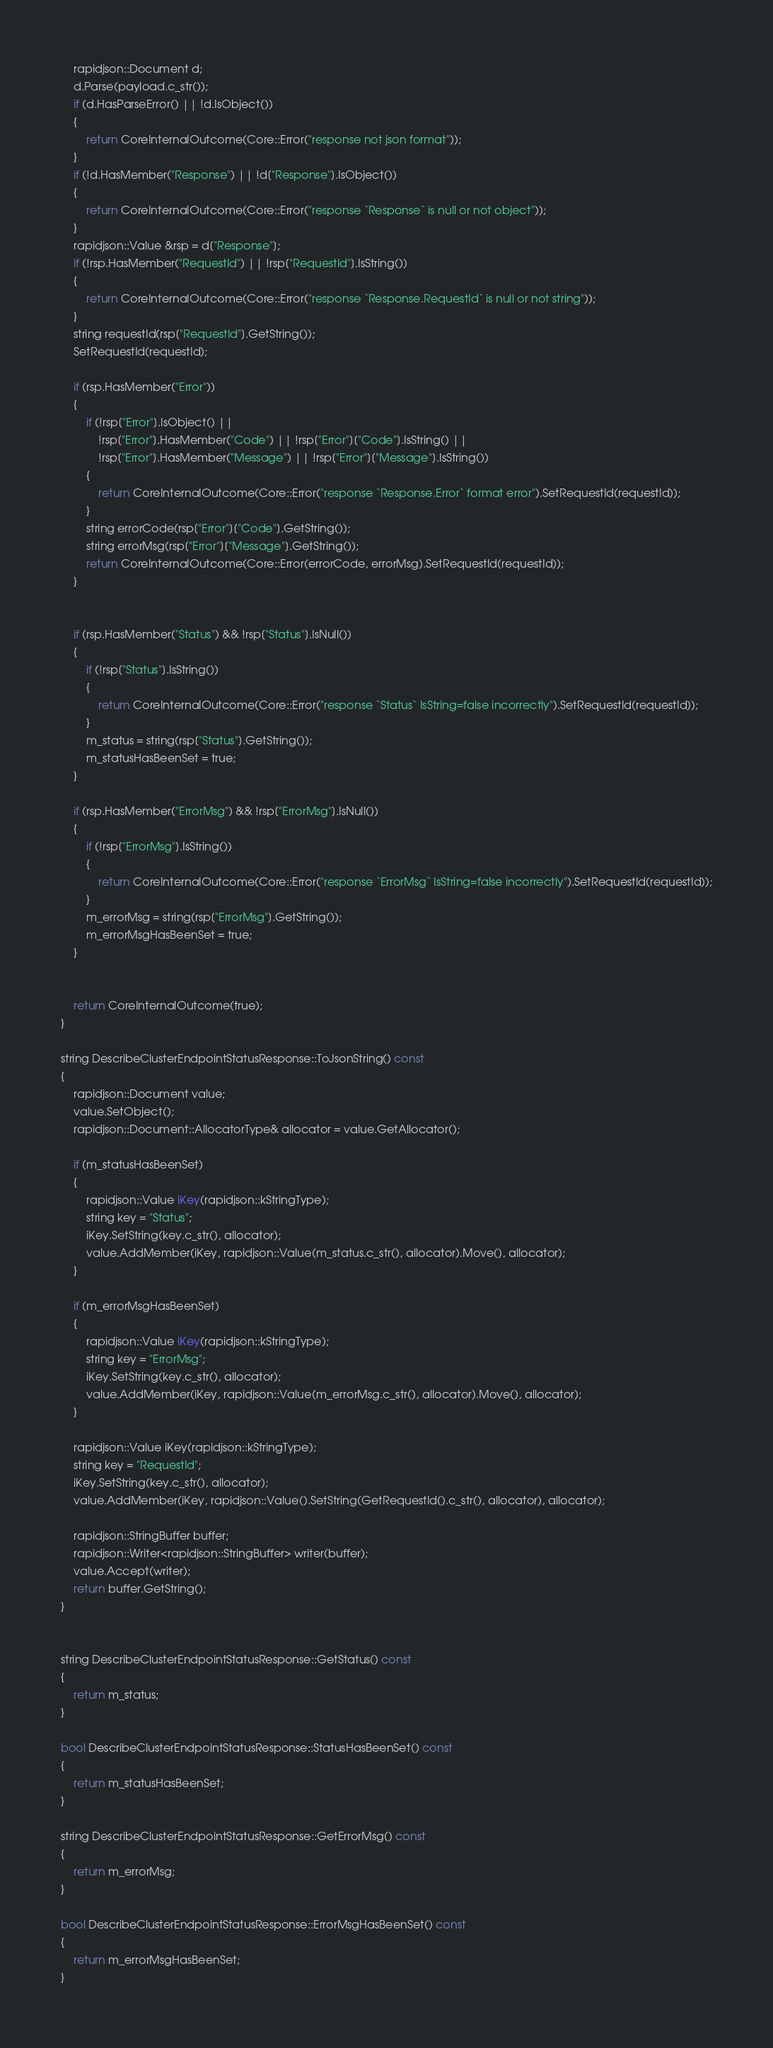<code> <loc_0><loc_0><loc_500><loc_500><_C++_>    rapidjson::Document d;
    d.Parse(payload.c_str());
    if (d.HasParseError() || !d.IsObject())
    {
        return CoreInternalOutcome(Core::Error("response not json format"));
    }
    if (!d.HasMember("Response") || !d["Response"].IsObject())
    {
        return CoreInternalOutcome(Core::Error("response `Response` is null or not object"));
    }
    rapidjson::Value &rsp = d["Response"];
    if (!rsp.HasMember("RequestId") || !rsp["RequestId"].IsString())
    {
        return CoreInternalOutcome(Core::Error("response `Response.RequestId` is null or not string"));
    }
    string requestId(rsp["RequestId"].GetString());
    SetRequestId(requestId);

    if (rsp.HasMember("Error"))
    {
        if (!rsp["Error"].IsObject() ||
            !rsp["Error"].HasMember("Code") || !rsp["Error"]["Code"].IsString() ||
            !rsp["Error"].HasMember("Message") || !rsp["Error"]["Message"].IsString())
        {
            return CoreInternalOutcome(Core::Error("response `Response.Error` format error").SetRequestId(requestId));
        }
        string errorCode(rsp["Error"]["Code"].GetString());
        string errorMsg(rsp["Error"]["Message"].GetString());
        return CoreInternalOutcome(Core::Error(errorCode, errorMsg).SetRequestId(requestId));
    }


    if (rsp.HasMember("Status") && !rsp["Status"].IsNull())
    {
        if (!rsp["Status"].IsString())
        {
            return CoreInternalOutcome(Core::Error("response `Status` IsString=false incorrectly").SetRequestId(requestId));
        }
        m_status = string(rsp["Status"].GetString());
        m_statusHasBeenSet = true;
    }

    if (rsp.HasMember("ErrorMsg") && !rsp["ErrorMsg"].IsNull())
    {
        if (!rsp["ErrorMsg"].IsString())
        {
            return CoreInternalOutcome(Core::Error("response `ErrorMsg` IsString=false incorrectly").SetRequestId(requestId));
        }
        m_errorMsg = string(rsp["ErrorMsg"].GetString());
        m_errorMsgHasBeenSet = true;
    }


    return CoreInternalOutcome(true);
}

string DescribeClusterEndpointStatusResponse::ToJsonString() const
{
    rapidjson::Document value;
    value.SetObject();
    rapidjson::Document::AllocatorType& allocator = value.GetAllocator();

    if (m_statusHasBeenSet)
    {
        rapidjson::Value iKey(rapidjson::kStringType);
        string key = "Status";
        iKey.SetString(key.c_str(), allocator);
        value.AddMember(iKey, rapidjson::Value(m_status.c_str(), allocator).Move(), allocator);
    }

    if (m_errorMsgHasBeenSet)
    {
        rapidjson::Value iKey(rapidjson::kStringType);
        string key = "ErrorMsg";
        iKey.SetString(key.c_str(), allocator);
        value.AddMember(iKey, rapidjson::Value(m_errorMsg.c_str(), allocator).Move(), allocator);
    }

    rapidjson::Value iKey(rapidjson::kStringType);
    string key = "RequestId";
    iKey.SetString(key.c_str(), allocator);
    value.AddMember(iKey, rapidjson::Value().SetString(GetRequestId().c_str(), allocator), allocator);
    
    rapidjson::StringBuffer buffer;
    rapidjson::Writer<rapidjson::StringBuffer> writer(buffer);
    value.Accept(writer);
    return buffer.GetString();
}


string DescribeClusterEndpointStatusResponse::GetStatus() const
{
    return m_status;
}

bool DescribeClusterEndpointStatusResponse::StatusHasBeenSet() const
{
    return m_statusHasBeenSet;
}

string DescribeClusterEndpointStatusResponse::GetErrorMsg() const
{
    return m_errorMsg;
}

bool DescribeClusterEndpointStatusResponse::ErrorMsgHasBeenSet() const
{
    return m_errorMsgHasBeenSet;
}


</code> 